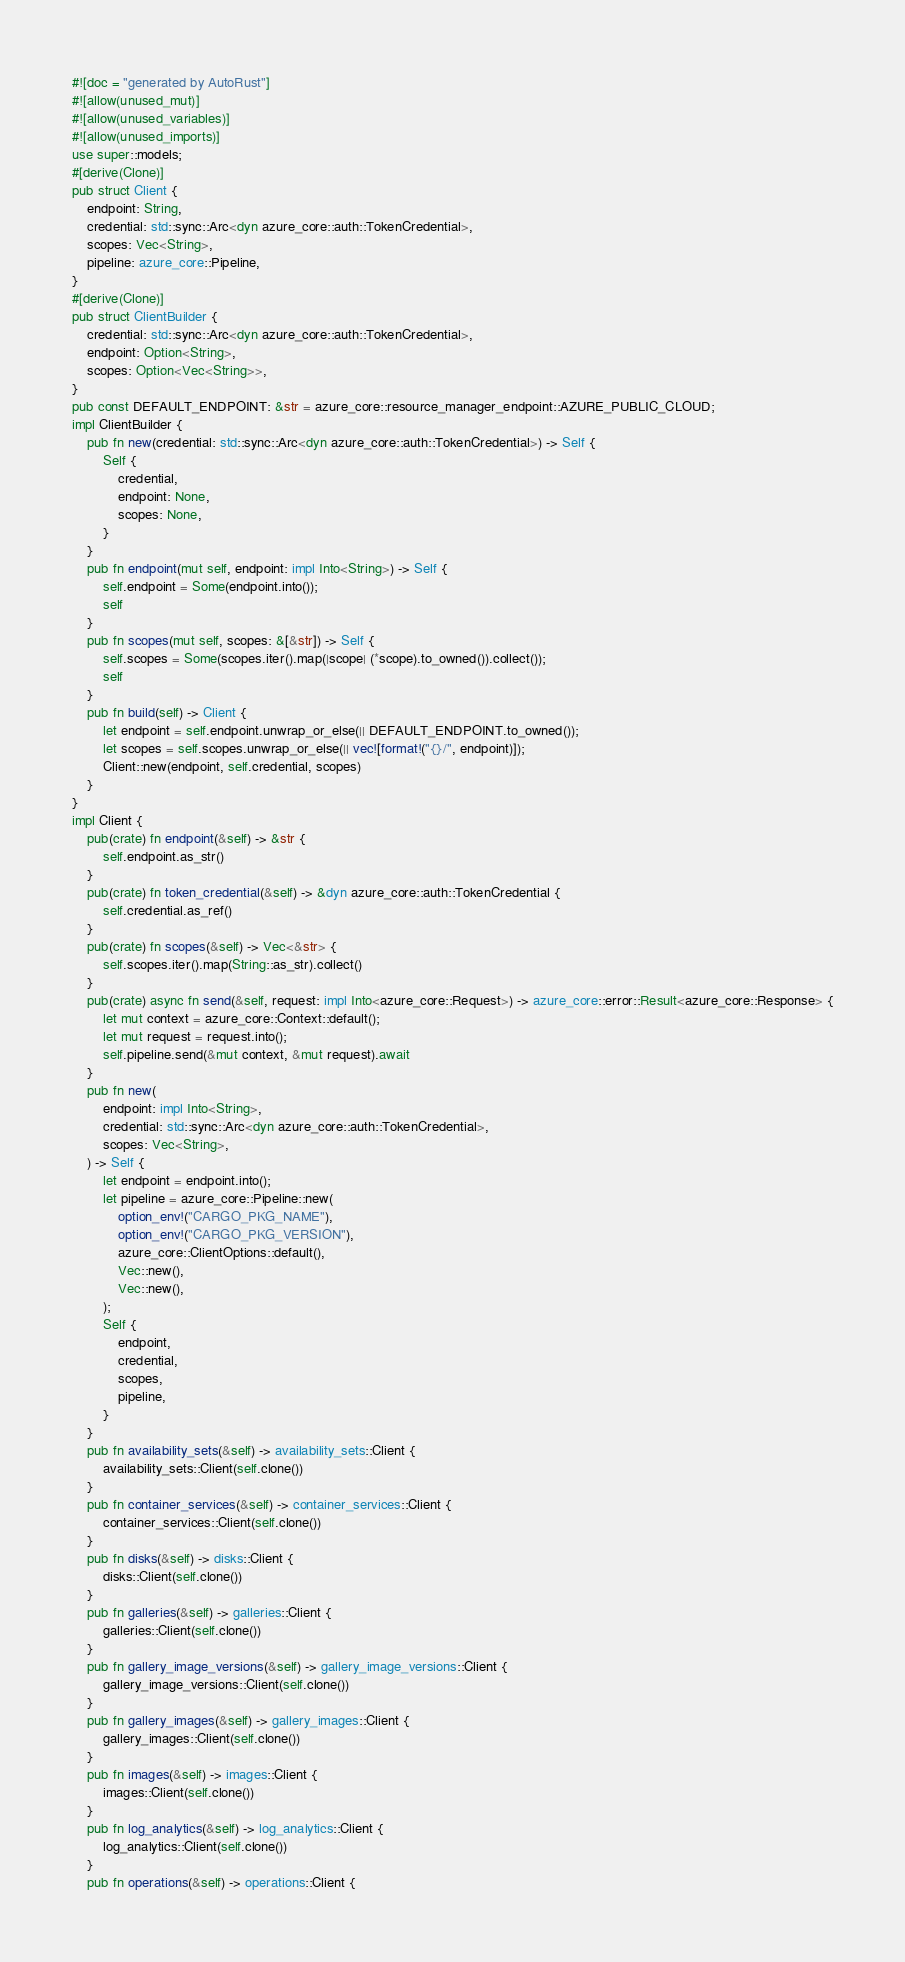Convert code to text. <code><loc_0><loc_0><loc_500><loc_500><_Rust_>#![doc = "generated by AutoRust"]
#![allow(unused_mut)]
#![allow(unused_variables)]
#![allow(unused_imports)]
use super::models;
#[derive(Clone)]
pub struct Client {
    endpoint: String,
    credential: std::sync::Arc<dyn azure_core::auth::TokenCredential>,
    scopes: Vec<String>,
    pipeline: azure_core::Pipeline,
}
#[derive(Clone)]
pub struct ClientBuilder {
    credential: std::sync::Arc<dyn azure_core::auth::TokenCredential>,
    endpoint: Option<String>,
    scopes: Option<Vec<String>>,
}
pub const DEFAULT_ENDPOINT: &str = azure_core::resource_manager_endpoint::AZURE_PUBLIC_CLOUD;
impl ClientBuilder {
    pub fn new(credential: std::sync::Arc<dyn azure_core::auth::TokenCredential>) -> Self {
        Self {
            credential,
            endpoint: None,
            scopes: None,
        }
    }
    pub fn endpoint(mut self, endpoint: impl Into<String>) -> Self {
        self.endpoint = Some(endpoint.into());
        self
    }
    pub fn scopes(mut self, scopes: &[&str]) -> Self {
        self.scopes = Some(scopes.iter().map(|scope| (*scope).to_owned()).collect());
        self
    }
    pub fn build(self) -> Client {
        let endpoint = self.endpoint.unwrap_or_else(|| DEFAULT_ENDPOINT.to_owned());
        let scopes = self.scopes.unwrap_or_else(|| vec![format!("{}/", endpoint)]);
        Client::new(endpoint, self.credential, scopes)
    }
}
impl Client {
    pub(crate) fn endpoint(&self) -> &str {
        self.endpoint.as_str()
    }
    pub(crate) fn token_credential(&self) -> &dyn azure_core::auth::TokenCredential {
        self.credential.as_ref()
    }
    pub(crate) fn scopes(&self) -> Vec<&str> {
        self.scopes.iter().map(String::as_str).collect()
    }
    pub(crate) async fn send(&self, request: impl Into<azure_core::Request>) -> azure_core::error::Result<azure_core::Response> {
        let mut context = azure_core::Context::default();
        let mut request = request.into();
        self.pipeline.send(&mut context, &mut request).await
    }
    pub fn new(
        endpoint: impl Into<String>,
        credential: std::sync::Arc<dyn azure_core::auth::TokenCredential>,
        scopes: Vec<String>,
    ) -> Self {
        let endpoint = endpoint.into();
        let pipeline = azure_core::Pipeline::new(
            option_env!("CARGO_PKG_NAME"),
            option_env!("CARGO_PKG_VERSION"),
            azure_core::ClientOptions::default(),
            Vec::new(),
            Vec::new(),
        );
        Self {
            endpoint,
            credential,
            scopes,
            pipeline,
        }
    }
    pub fn availability_sets(&self) -> availability_sets::Client {
        availability_sets::Client(self.clone())
    }
    pub fn container_services(&self) -> container_services::Client {
        container_services::Client(self.clone())
    }
    pub fn disks(&self) -> disks::Client {
        disks::Client(self.clone())
    }
    pub fn galleries(&self) -> galleries::Client {
        galleries::Client(self.clone())
    }
    pub fn gallery_image_versions(&self) -> gallery_image_versions::Client {
        gallery_image_versions::Client(self.clone())
    }
    pub fn gallery_images(&self) -> gallery_images::Client {
        gallery_images::Client(self.clone())
    }
    pub fn images(&self) -> images::Client {
        images::Client(self.clone())
    }
    pub fn log_analytics(&self) -> log_analytics::Client {
        log_analytics::Client(self.clone())
    }
    pub fn operations(&self) -> operations::Client {</code> 